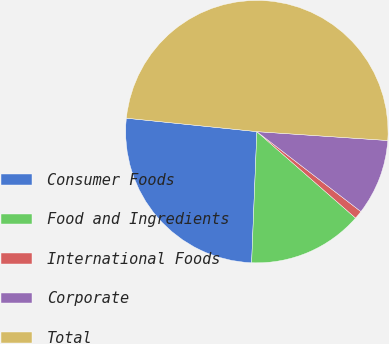Convert chart to OTSL. <chart><loc_0><loc_0><loc_500><loc_500><pie_chart><fcel>Consumer Foods<fcel>Food and Ingredients<fcel>International Foods<fcel>Corporate<fcel>Total<nl><fcel>26.0%<fcel>14.19%<fcel>1.02%<fcel>9.35%<fcel>49.45%<nl></chart> 